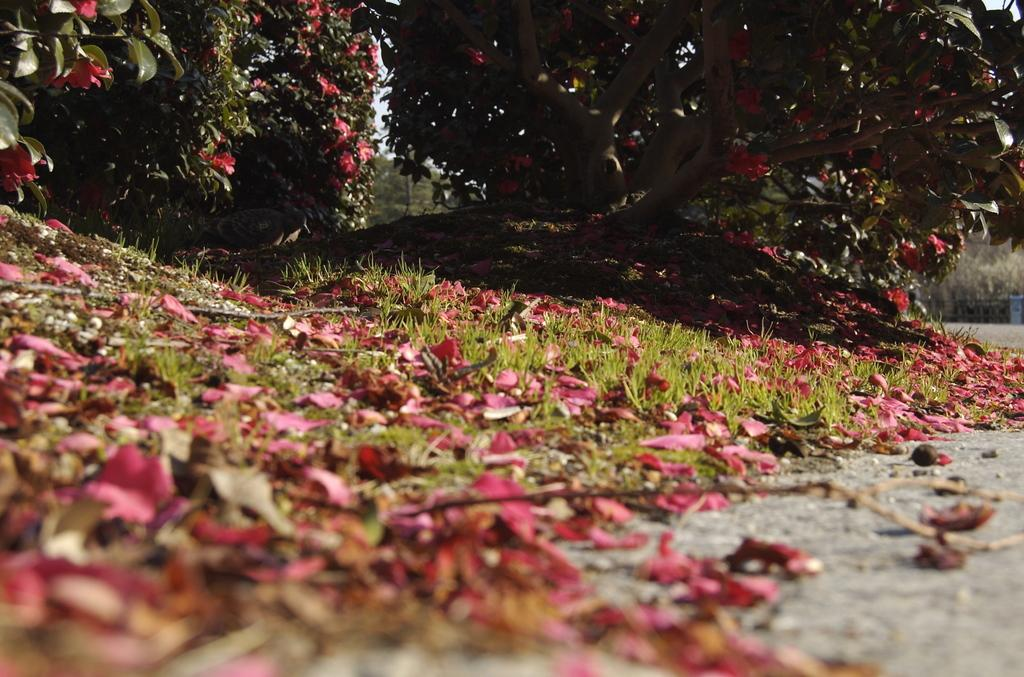What is located in the center of the image? There are flower petals and grassland in the center of the image. What type of vegetation is present at the top side of the image? There are flower plants at the top side of the image. How many cars are parked on the grassland in the image? There are no cars present in the image; it features flower petals, grassland, and flower plants. What is the size of the chessboard in the image? There is no chessboard present in the image. 